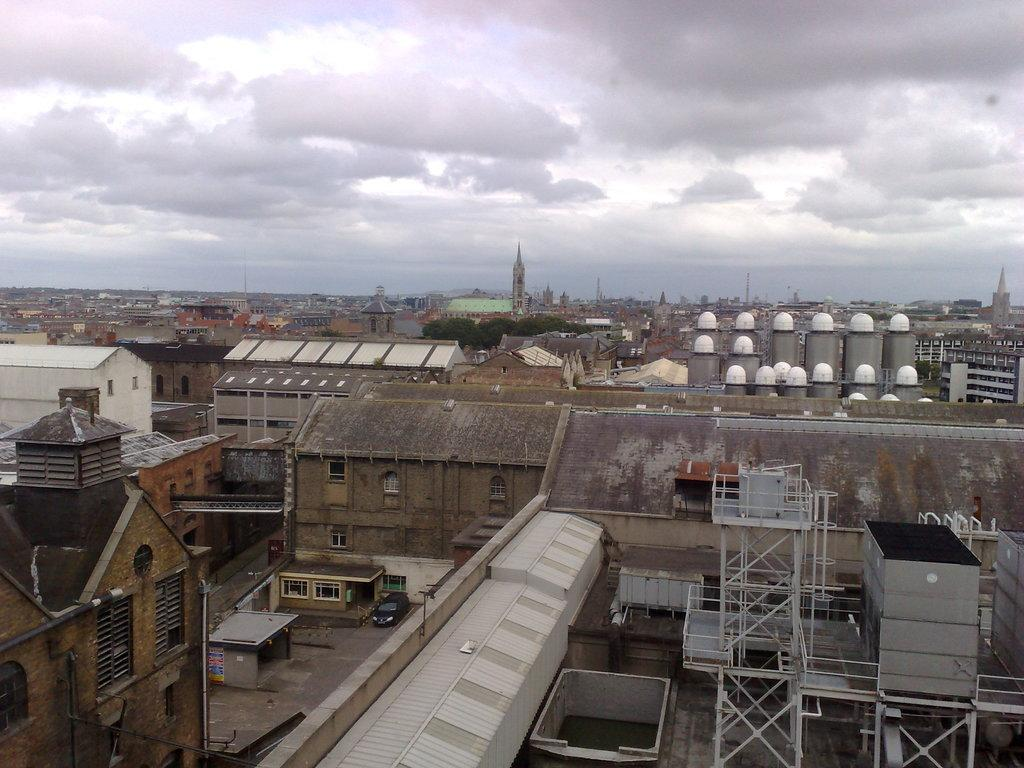What type of structures can be seen in the image? There are buildings in the image. What else is present in the image besides buildings? There are vehicles and poles visible in the image. What can be seen in the sky in the image? Clouds and the sky are visible at the top of the image. What type of clover is growing on the roof of the building in the image? There is no clover present in the image; it is a photograph of buildings, vehicles, and poles with clouds and the sky visible at the top. 